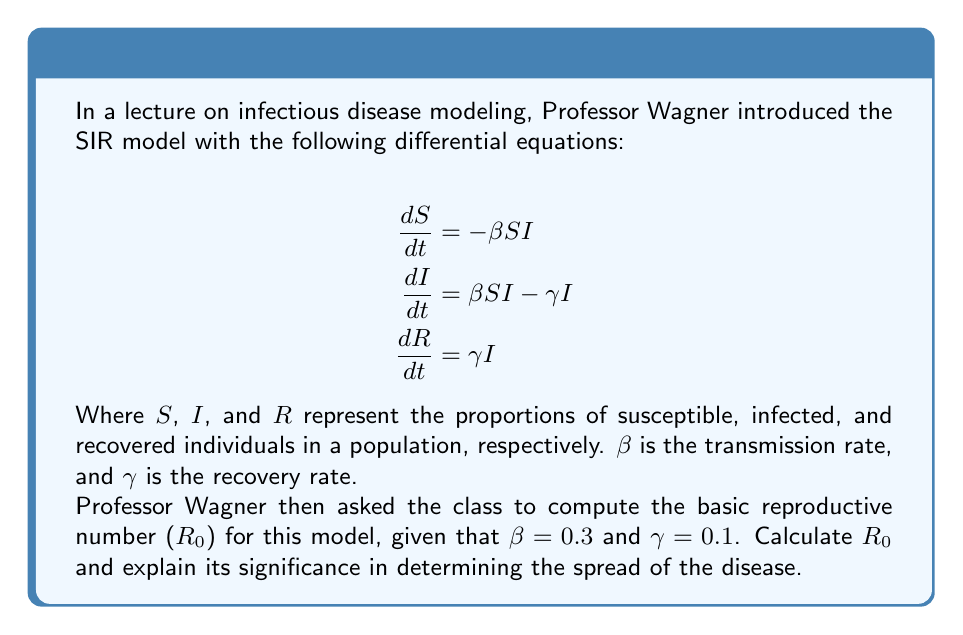Solve this math problem. To solve this problem, let's follow these steps:

1) The basic reproductive number ($R_0$) for the SIR model is given by the formula:

   $$R_0 = \frac{\beta}{\gamma}$$

   This represents the average number of secondary infections caused by one infected individual in a completely susceptible population.

2) We are given:
   $\beta = 0.3$ (transmission rate)
   $\gamma = 0.1$ (recovery rate)

3) Let's substitute these values into the formula:

   $$R_0 = \frac{0.3}{0.1}$$

4) Simplify:
   
   $$R_0 = 3$$

5) Interpretation:
   - If $R_0 > 1$, the disease will spread in the population.
   - If $R_0 < 1$, the disease will die out.
   - If $R_0 = 1$, the disease will become endemic.

   In this case, $R_0 = 3 > 1$, which means that on average, each infected person will infect 3 others before recovering. This indicates that the disease will spread in the population.

6) Significance:
   The $R_0$ value is crucial for understanding and predicting the initial spread of an infectious disease. It helps public health officials determine the intensity of interventions needed to control an outbreak. A higher $R_0$ implies that more aggressive measures may be necessary to contain the spread of the disease.
Answer: $R_0 = 3$ 